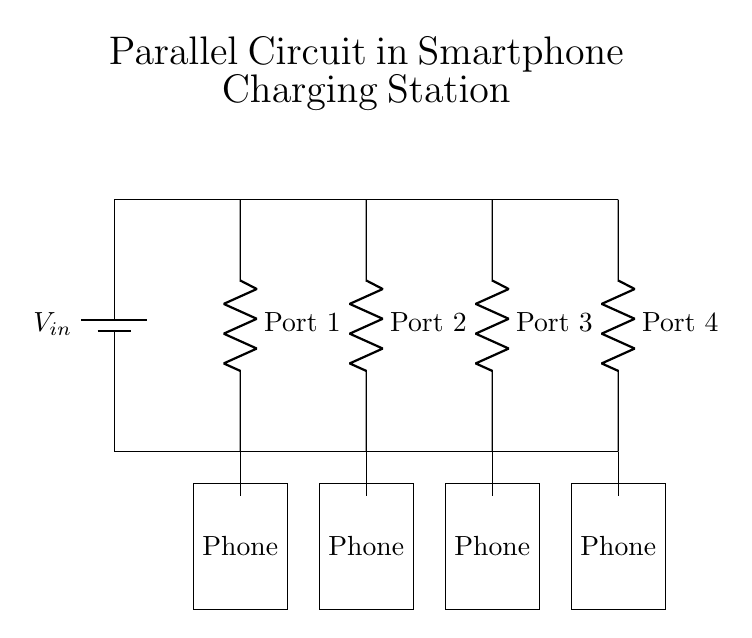What is the power source in this circuit? The power source is represented by the battery symbol at the top left corner of the diagram. This indicates that the circuit is powered by a battery.
Answer: Battery How many charging ports are there? The diagram clearly shows four separate charging ports labeled as Port 1, Port 2, Port 3, and Port 4. Each port provides a connection for a device.
Answer: Four What type of circuit is this? The configuration of the circuit, where multiple components share the same two nodes independently, represents a parallel circuit. This can be identified by the layout of branches connecting to the same power source.
Answer: Parallel What do the rectangles at the bottom represent? Each rectangle labeled as "Phone" at the bottom of the diagram represents a smartphone connected to each charging port. This indicates that each port charges a separate phone.
Answer: Smartphones What happens to the current if one smartphone is disconnected? In a parallel circuit configuration, disconnecting one component does not affect the current flowing to the other components, as each has its own path to the power source. Therefore, the rest will continue to charge uninterrupted.
Answer: Current remains unchanged Which component regulates voltage in this circuit? In this specific circuit diagram, resistors at each port may be used to regulate voltage to the smartphones. They ensure that the voltage supplied to each phone does not exceed the safe charging level.
Answer: Resistors 